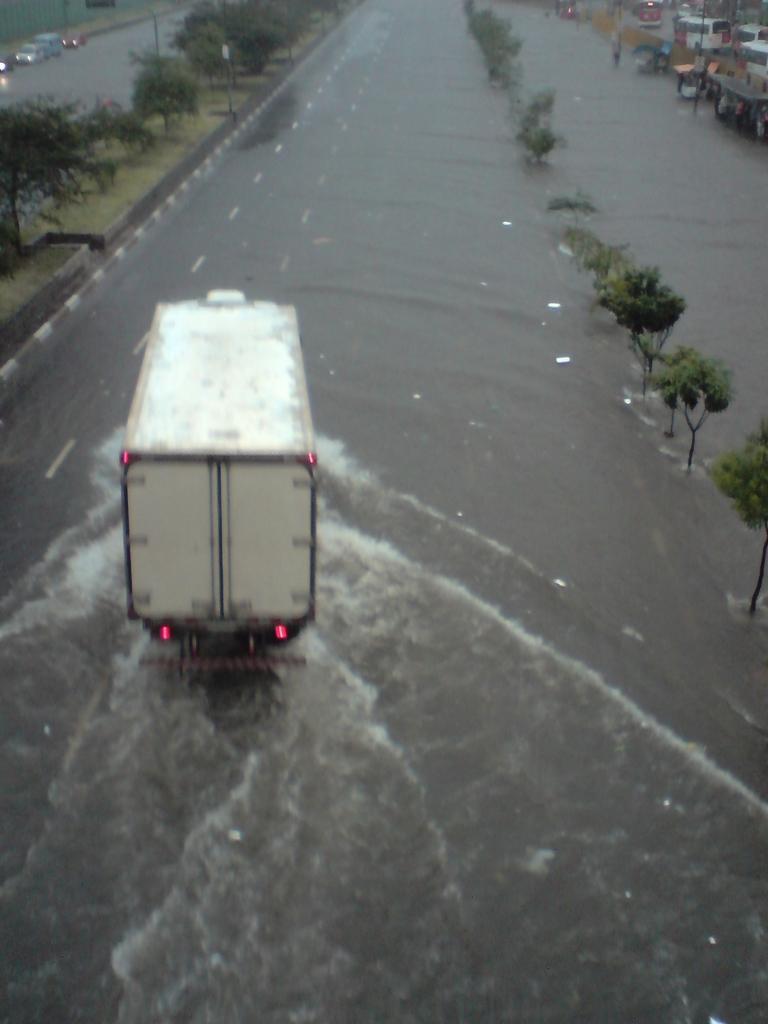Can you describe this image briefly? In this image we can see group of vehicles parked on the road. In the foreground we can see water. In the background we can see group of trees and some items placed on ground. 